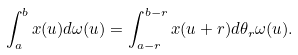<formula> <loc_0><loc_0><loc_500><loc_500>\int _ { a } ^ { b } x ( u ) d \omega ( u ) = \int _ { a - r } ^ { b - r } x ( u + r ) d \theta _ { r } \omega ( u ) .</formula> 